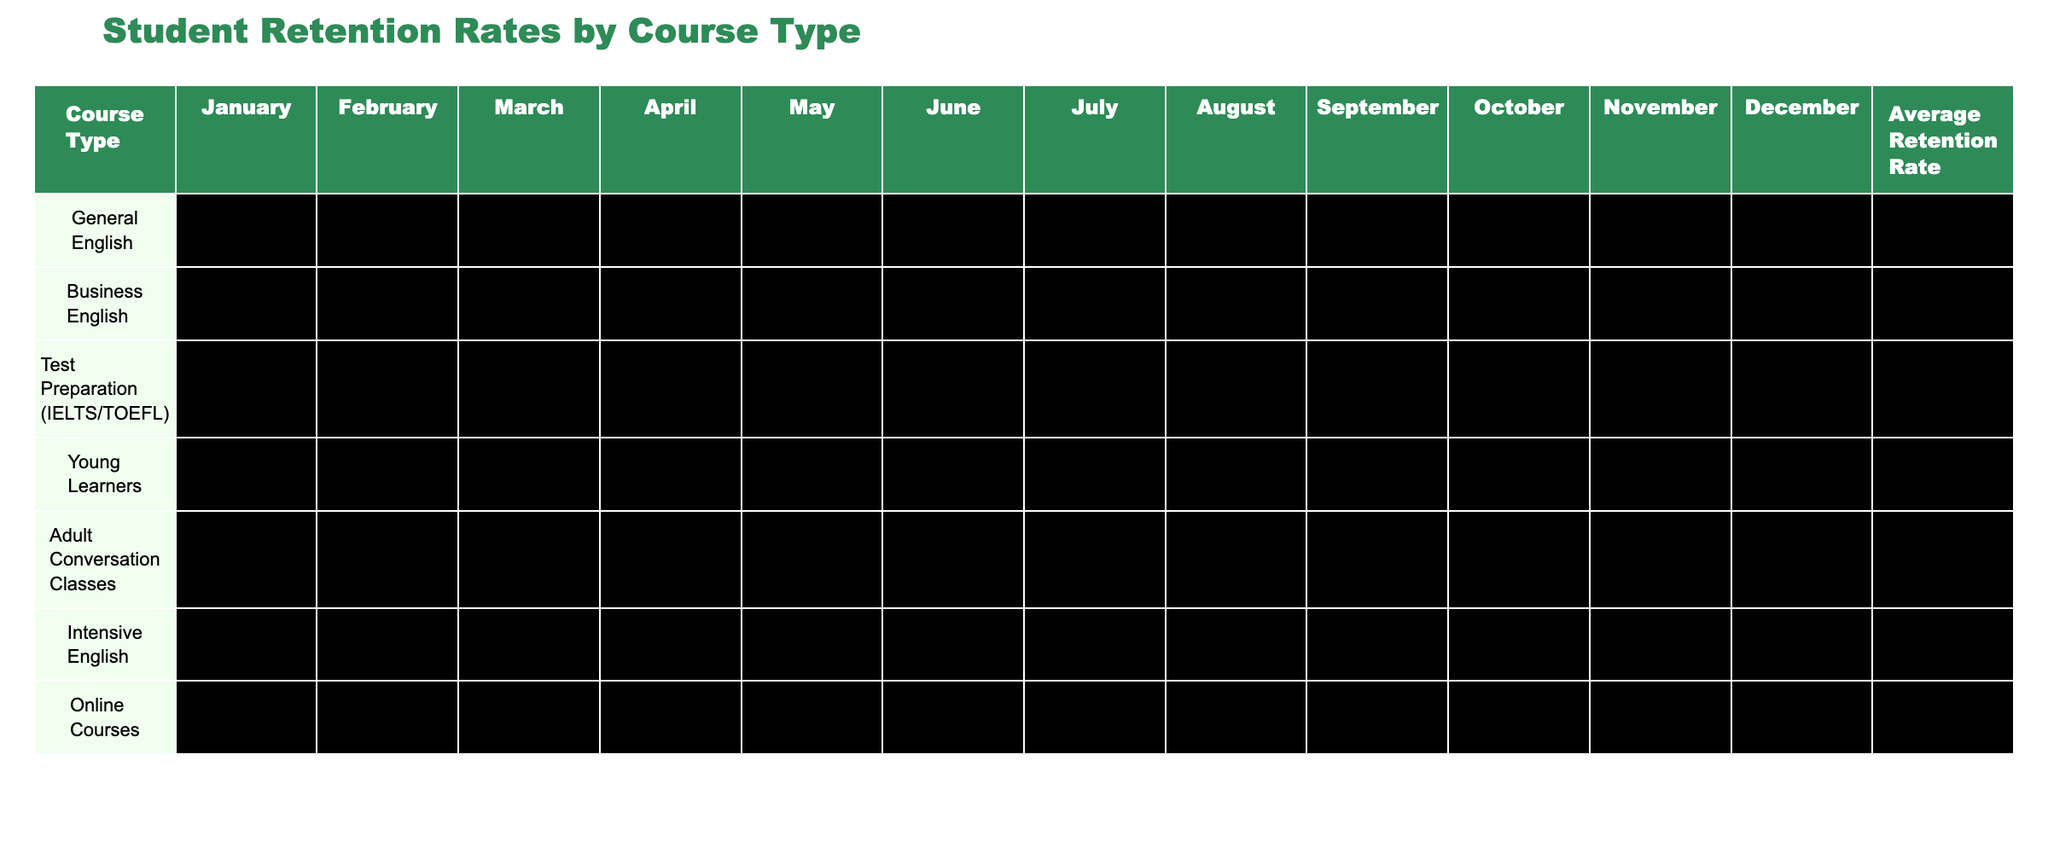What was the average retention rate for Online Courses? The average retention rate for Online Courses is displayed in the last column of the table, which lists the average rate as 83.25.
Answer: 83.25 Which course type had the highest retention rate in March? By examining the March column, Intensive English has the highest retention rate at 90.
Answer: 90 Is the average retention rate for Young Learners above or below 80? The average retention rate for Young Learners is 78.75, which is below 80.
Answer: Below What is the difference in average retention rates between General English and Business English? The average retention rate for General English is 84.75, and for Business English, it is 76.25. The difference is 84.75 - 76.25 = 8.50.
Answer: 8.50 Which months did Intensive English have a retention rate below 88? In the table, the months with a retention rate below 88 for Intensive English are May (86) and October (87).
Answer: May and October For which course type was the retention rate the most consistent throughout the year? By comparing the retention rates across months, Business English shows the smallest variation, with rates consistently in the lower 70s to upper 80s.
Answer: Business English What is the average retention rate across all course types displayed? To find the overall average, each average retention rate is summed, which equals 84.75 + 76.25 + 89.75 + 78.75 + 84.25 + 88.25 + 83.25 = 85.29, then divided by 7 courses results in approximately 85.29.
Answer: 85.29 Which course had the lowest average retention rate and what was it? The lowest average retention rate can be found in the last column; Business English at 76.25 is the lowest.
Answer: Business English, 76.25 Did the retention rate for Adult Conversation Classes increase or decrease from February to June? In the table, the retention rate for Adult Conversation Classes decreased from February (84) to March (83), but then increased to 88 in June.
Answer: Increase Which course had a retention rate of 95 in December? The December column shows that the retention rate of 95 was achieved by Test Preparation (IELTS/TOEFL).
Answer: Test Preparation (IELTS/TOEFL) 